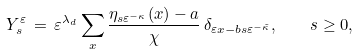<formula> <loc_0><loc_0><loc_500><loc_500>Y _ { s } ^ { \varepsilon } \, = \, \varepsilon ^ { \lambda _ { d } } \sum _ { x } \frac { \eta _ { s \varepsilon ^ { - \kappa } } ( x ) - a } { \chi } \, \delta _ { \varepsilon x - b s \varepsilon ^ { - \tilde { \kappa } } } , \quad s \geq 0 ,</formula> 